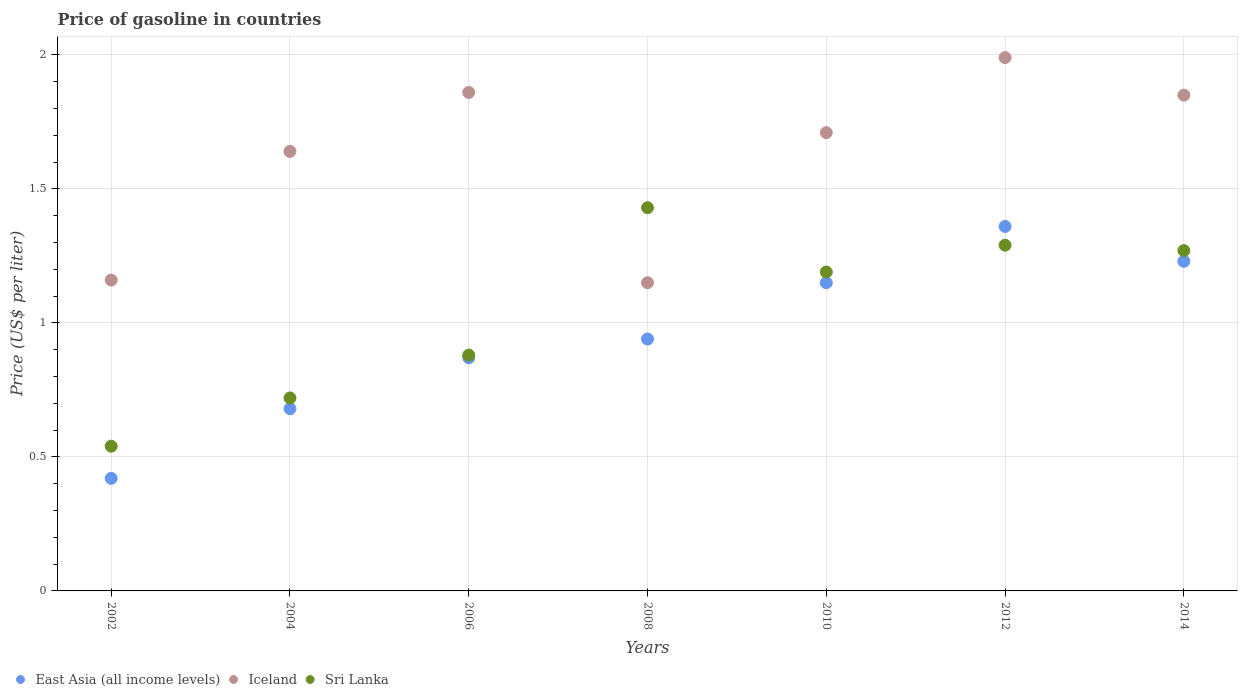How many different coloured dotlines are there?
Ensure brevity in your answer.  3. Is the number of dotlines equal to the number of legend labels?
Provide a short and direct response. Yes. What is the price of gasoline in Iceland in 2012?
Offer a terse response. 1.99. Across all years, what is the maximum price of gasoline in Iceland?
Your answer should be very brief. 1.99. Across all years, what is the minimum price of gasoline in East Asia (all income levels)?
Your answer should be compact. 0.42. In which year was the price of gasoline in Iceland minimum?
Give a very brief answer. 2008. What is the total price of gasoline in Iceland in the graph?
Offer a terse response. 11.36. What is the difference between the price of gasoline in Sri Lanka in 2008 and that in 2014?
Offer a terse response. 0.16. What is the difference between the price of gasoline in East Asia (all income levels) in 2014 and the price of gasoline in Sri Lanka in 2010?
Make the answer very short. 0.04. What is the average price of gasoline in Iceland per year?
Provide a short and direct response. 1.62. In the year 2008, what is the difference between the price of gasoline in Sri Lanka and price of gasoline in Iceland?
Keep it short and to the point. 0.28. What is the ratio of the price of gasoline in Sri Lanka in 2002 to that in 2006?
Your response must be concise. 0.61. Is the price of gasoline in Iceland in 2008 less than that in 2014?
Your response must be concise. Yes. Is the difference between the price of gasoline in Sri Lanka in 2002 and 2006 greater than the difference between the price of gasoline in Iceland in 2002 and 2006?
Offer a very short reply. Yes. What is the difference between the highest and the second highest price of gasoline in Iceland?
Make the answer very short. 0.13. What is the difference between the highest and the lowest price of gasoline in Sri Lanka?
Provide a succinct answer. 0.89. Is it the case that in every year, the sum of the price of gasoline in East Asia (all income levels) and price of gasoline in Iceland  is greater than the price of gasoline in Sri Lanka?
Keep it short and to the point. Yes. Does the price of gasoline in Sri Lanka monotonically increase over the years?
Give a very brief answer. No. Is the price of gasoline in Iceland strictly greater than the price of gasoline in East Asia (all income levels) over the years?
Offer a very short reply. Yes. Is the price of gasoline in Sri Lanka strictly less than the price of gasoline in Iceland over the years?
Your answer should be very brief. No. How many dotlines are there?
Offer a terse response. 3. How many years are there in the graph?
Offer a terse response. 7. What is the difference between two consecutive major ticks on the Y-axis?
Your answer should be compact. 0.5. Are the values on the major ticks of Y-axis written in scientific E-notation?
Provide a succinct answer. No. Does the graph contain grids?
Provide a short and direct response. Yes. How many legend labels are there?
Keep it short and to the point. 3. How are the legend labels stacked?
Offer a terse response. Horizontal. What is the title of the graph?
Ensure brevity in your answer.  Price of gasoline in countries. What is the label or title of the Y-axis?
Provide a short and direct response. Price (US$ per liter). What is the Price (US$ per liter) of East Asia (all income levels) in 2002?
Make the answer very short. 0.42. What is the Price (US$ per liter) in Iceland in 2002?
Ensure brevity in your answer.  1.16. What is the Price (US$ per liter) in Sri Lanka in 2002?
Offer a terse response. 0.54. What is the Price (US$ per liter) in East Asia (all income levels) in 2004?
Provide a short and direct response. 0.68. What is the Price (US$ per liter) of Iceland in 2004?
Your response must be concise. 1.64. What is the Price (US$ per liter) in Sri Lanka in 2004?
Offer a terse response. 0.72. What is the Price (US$ per liter) in East Asia (all income levels) in 2006?
Offer a very short reply. 0.87. What is the Price (US$ per liter) in Iceland in 2006?
Your response must be concise. 1.86. What is the Price (US$ per liter) in Sri Lanka in 2006?
Give a very brief answer. 0.88. What is the Price (US$ per liter) in East Asia (all income levels) in 2008?
Provide a short and direct response. 0.94. What is the Price (US$ per liter) of Iceland in 2008?
Your answer should be very brief. 1.15. What is the Price (US$ per liter) of Sri Lanka in 2008?
Your response must be concise. 1.43. What is the Price (US$ per liter) in East Asia (all income levels) in 2010?
Your answer should be compact. 1.15. What is the Price (US$ per liter) in Iceland in 2010?
Keep it short and to the point. 1.71. What is the Price (US$ per liter) in Sri Lanka in 2010?
Offer a very short reply. 1.19. What is the Price (US$ per liter) of East Asia (all income levels) in 2012?
Your answer should be very brief. 1.36. What is the Price (US$ per liter) of Iceland in 2012?
Offer a terse response. 1.99. What is the Price (US$ per liter) in Sri Lanka in 2012?
Offer a terse response. 1.29. What is the Price (US$ per liter) of East Asia (all income levels) in 2014?
Provide a succinct answer. 1.23. What is the Price (US$ per liter) of Iceland in 2014?
Give a very brief answer. 1.85. What is the Price (US$ per liter) in Sri Lanka in 2014?
Your response must be concise. 1.27. Across all years, what is the maximum Price (US$ per liter) in East Asia (all income levels)?
Provide a succinct answer. 1.36. Across all years, what is the maximum Price (US$ per liter) in Iceland?
Offer a terse response. 1.99. Across all years, what is the maximum Price (US$ per liter) in Sri Lanka?
Ensure brevity in your answer.  1.43. Across all years, what is the minimum Price (US$ per liter) in East Asia (all income levels)?
Your response must be concise. 0.42. Across all years, what is the minimum Price (US$ per liter) of Iceland?
Keep it short and to the point. 1.15. Across all years, what is the minimum Price (US$ per liter) of Sri Lanka?
Ensure brevity in your answer.  0.54. What is the total Price (US$ per liter) in East Asia (all income levels) in the graph?
Keep it short and to the point. 6.65. What is the total Price (US$ per liter) in Iceland in the graph?
Your answer should be very brief. 11.36. What is the total Price (US$ per liter) of Sri Lanka in the graph?
Offer a terse response. 7.32. What is the difference between the Price (US$ per liter) of East Asia (all income levels) in 2002 and that in 2004?
Ensure brevity in your answer.  -0.26. What is the difference between the Price (US$ per liter) of Iceland in 2002 and that in 2004?
Your answer should be compact. -0.48. What is the difference between the Price (US$ per liter) in Sri Lanka in 2002 and that in 2004?
Your answer should be compact. -0.18. What is the difference between the Price (US$ per liter) of East Asia (all income levels) in 2002 and that in 2006?
Provide a short and direct response. -0.45. What is the difference between the Price (US$ per liter) of Iceland in 2002 and that in 2006?
Provide a succinct answer. -0.7. What is the difference between the Price (US$ per liter) in Sri Lanka in 2002 and that in 2006?
Keep it short and to the point. -0.34. What is the difference between the Price (US$ per liter) in East Asia (all income levels) in 2002 and that in 2008?
Provide a succinct answer. -0.52. What is the difference between the Price (US$ per liter) in Iceland in 2002 and that in 2008?
Offer a very short reply. 0.01. What is the difference between the Price (US$ per liter) of Sri Lanka in 2002 and that in 2008?
Your response must be concise. -0.89. What is the difference between the Price (US$ per liter) in East Asia (all income levels) in 2002 and that in 2010?
Keep it short and to the point. -0.73. What is the difference between the Price (US$ per liter) in Iceland in 2002 and that in 2010?
Your response must be concise. -0.55. What is the difference between the Price (US$ per liter) in Sri Lanka in 2002 and that in 2010?
Offer a terse response. -0.65. What is the difference between the Price (US$ per liter) in East Asia (all income levels) in 2002 and that in 2012?
Make the answer very short. -0.94. What is the difference between the Price (US$ per liter) in Iceland in 2002 and that in 2012?
Ensure brevity in your answer.  -0.83. What is the difference between the Price (US$ per liter) in Sri Lanka in 2002 and that in 2012?
Provide a succinct answer. -0.75. What is the difference between the Price (US$ per liter) in East Asia (all income levels) in 2002 and that in 2014?
Provide a short and direct response. -0.81. What is the difference between the Price (US$ per liter) of Iceland in 2002 and that in 2014?
Provide a succinct answer. -0.69. What is the difference between the Price (US$ per liter) of Sri Lanka in 2002 and that in 2014?
Offer a terse response. -0.73. What is the difference between the Price (US$ per liter) of East Asia (all income levels) in 2004 and that in 2006?
Ensure brevity in your answer.  -0.19. What is the difference between the Price (US$ per liter) of Iceland in 2004 and that in 2006?
Provide a short and direct response. -0.22. What is the difference between the Price (US$ per liter) in Sri Lanka in 2004 and that in 2006?
Ensure brevity in your answer.  -0.16. What is the difference between the Price (US$ per liter) in East Asia (all income levels) in 2004 and that in 2008?
Offer a terse response. -0.26. What is the difference between the Price (US$ per liter) of Iceland in 2004 and that in 2008?
Provide a succinct answer. 0.49. What is the difference between the Price (US$ per liter) in Sri Lanka in 2004 and that in 2008?
Ensure brevity in your answer.  -0.71. What is the difference between the Price (US$ per liter) of East Asia (all income levels) in 2004 and that in 2010?
Provide a short and direct response. -0.47. What is the difference between the Price (US$ per liter) of Iceland in 2004 and that in 2010?
Offer a very short reply. -0.07. What is the difference between the Price (US$ per liter) of Sri Lanka in 2004 and that in 2010?
Provide a succinct answer. -0.47. What is the difference between the Price (US$ per liter) of East Asia (all income levels) in 2004 and that in 2012?
Offer a very short reply. -0.68. What is the difference between the Price (US$ per liter) of Iceland in 2004 and that in 2012?
Give a very brief answer. -0.35. What is the difference between the Price (US$ per liter) of Sri Lanka in 2004 and that in 2012?
Provide a succinct answer. -0.57. What is the difference between the Price (US$ per liter) in East Asia (all income levels) in 2004 and that in 2014?
Your answer should be compact. -0.55. What is the difference between the Price (US$ per liter) of Iceland in 2004 and that in 2014?
Provide a short and direct response. -0.21. What is the difference between the Price (US$ per liter) of Sri Lanka in 2004 and that in 2014?
Ensure brevity in your answer.  -0.55. What is the difference between the Price (US$ per liter) in East Asia (all income levels) in 2006 and that in 2008?
Provide a succinct answer. -0.07. What is the difference between the Price (US$ per liter) in Iceland in 2006 and that in 2008?
Offer a very short reply. 0.71. What is the difference between the Price (US$ per liter) in Sri Lanka in 2006 and that in 2008?
Ensure brevity in your answer.  -0.55. What is the difference between the Price (US$ per liter) in East Asia (all income levels) in 2006 and that in 2010?
Offer a terse response. -0.28. What is the difference between the Price (US$ per liter) of Iceland in 2006 and that in 2010?
Your response must be concise. 0.15. What is the difference between the Price (US$ per liter) in Sri Lanka in 2006 and that in 2010?
Provide a short and direct response. -0.31. What is the difference between the Price (US$ per liter) in East Asia (all income levels) in 2006 and that in 2012?
Offer a terse response. -0.49. What is the difference between the Price (US$ per liter) in Iceland in 2006 and that in 2012?
Ensure brevity in your answer.  -0.13. What is the difference between the Price (US$ per liter) of Sri Lanka in 2006 and that in 2012?
Provide a short and direct response. -0.41. What is the difference between the Price (US$ per liter) in East Asia (all income levels) in 2006 and that in 2014?
Your answer should be very brief. -0.36. What is the difference between the Price (US$ per liter) in Iceland in 2006 and that in 2014?
Make the answer very short. 0.01. What is the difference between the Price (US$ per liter) in Sri Lanka in 2006 and that in 2014?
Provide a succinct answer. -0.39. What is the difference between the Price (US$ per liter) of East Asia (all income levels) in 2008 and that in 2010?
Make the answer very short. -0.21. What is the difference between the Price (US$ per liter) in Iceland in 2008 and that in 2010?
Keep it short and to the point. -0.56. What is the difference between the Price (US$ per liter) in Sri Lanka in 2008 and that in 2010?
Keep it short and to the point. 0.24. What is the difference between the Price (US$ per liter) of East Asia (all income levels) in 2008 and that in 2012?
Offer a very short reply. -0.42. What is the difference between the Price (US$ per liter) in Iceland in 2008 and that in 2012?
Your answer should be compact. -0.84. What is the difference between the Price (US$ per liter) of Sri Lanka in 2008 and that in 2012?
Offer a very short reply. 0.14. What is the difference between the Price (US$ per liter) of East Asia (all income levels) in 2008 and that in 2014?
Ensure brevity in your answer.  -0.29. What is the difference between the Price (US$ per liter) in Iceland in 2008 and that in 2014?
Offer a terse response. -0.7. What is the difference between the Price (US$ per liter) in Sri Lanka in 2008 and that in 2014?
Your answer should be compact. 0.16. What is the difference between the Price (US$ per liter) in East Asia (all income levels) in 2010 and that in 2012?
Your answer should be very brief. -0.21. What is the difference between the Price (US$ per liter) of Iceland in 2010 and that in 2012?
Give a very brief answer. -0.28. What is the difference between the Price (US$ per liter) of East Asia (all income levels) in 2010 and that in 2014?
Provide a short and direct response. -0.08. What is the difference between the Price (US$ per liter) of Iceland in 2010 and that in 2014?
Make the answer very short. -0.14. What is the difference between the Price (US$ per liter) of Sri Lanka in 2010 and that in 2014?
Your response must be concise. -0.08. What is the difference between the Price (US$ per liter) of East Asia (all income levels) in 2012 and that in 2014?
Provide a short and direct response. 0.13. What is the difference between the Price (US$ per liter) of Iceland in 2012 and that in 2014?
Provide a short and direct response. 0.14. What is the difference between the Price (US$ per liter) of East Asia (all income levels) in 2002 and the Price (US$ per liter) of Iceland in 2004?
Make the answer very short. -1.22. What is the difference between the Price (US$ per liter) of East Asia (all income levels) in 2002 and the Price (US$ per liter) of Sri Lanka in 2004?
Give a very brief answer. -0.3. What is the difference between the Price (US$ per liter) in Iceland in 2002 and the Price (US$ per liter) in Sri Lanka in 2004?
Make the answer very short. 0.44. What is the difference between the Price (US$ per liter) of East Asia (all income levels) in 2002 and the Price (US$ per liter) of Iceland in 2006?
Provide a short and direct response. -1.44. What is the difference between the Price (US$ per liter) in East Asia (all income levels) in 2002 and the Price (US$ per liter) in Sri Lanka in 2006?
Ensure brevity in your answer.  -0.46. What is the difference between the Price (US$ per liter) of Iceland in 2002 and the Price (US$ per liter) of Sri Lanka in 2006?
Ensure brevity in your answer.  0.28. What is the difference between the Price (US$ per liter) of East Asia (all income levels) in 2002 and the Price (US$ per liter) of Iceland in 2008?
Give a very brief answer. -0.73. What is the difference between the Price (US$ per liter) in East Asia (all income levels) in 2002 and the Price (US$ per liter) in Sri Lanka in 2008?
Keep it short and to the point. -1.01. What is the difference between the Price (US$ per liter) of Iceland in 2002 and the Price (US$ per liter) of Sri Lanka in 2008?
Provide a succinct answer. -0.27. What is the difference between the Price (US$ per liter) in East Asia (all income levels) in 2002 and the Price (US$ per liter) in Iceland in 2010?
Give a very brief answer. -1.29. What is the difference between the Price (US$ per liter) of East Asia (all income levels) in 2002 and the Price (US$ per liter) of Sri Lanka in 2010?
Ensure brevity in your answer.  -0.77. What is the difference between the Price (US$ per liter) in Iceland in 2002 and the Price (US$ per liter) in Sri Lanka in 2010?
Keep it short and to the point. -0.03. What is the difference between the Price (US$ per liter) in East Asia (all income levels) in 2002 and the Price (US$ per liter) in Iceland in 2012?
Keep it short and to the point. -1.57. What is the difference between the Price (US$ per liter) of East Asia (all income levels) in 2002 and the Price (US$ per liter) of Sri Lanka in 2012?
Your answer should be compact. -0.87. What is the difference between the Price (US$ per liter) of Iceland in 2002 and the Price (US$ per liter) of Sri Lanka in 2012?
Offer a terse response. -0.13. What is the difference between the Price (US$ per liter) of East Asia (all income levels) in 2002 and the Price (US$ per liter) of Iceland in 2014?
Your answer should be very brief. -1.43. What is the difference between the Price (US$ per liter) in East Asia (all income levels) in 2002 and the Price (US$ per liter) in Sri Lanka in 2014?
Offer a very short reply. -0.85. What is the difference between the Price (US$ per liter) of Iceland in 2002 and the Price (US$ per liter) of Sri Lanka in 2014?
Ensure brevity in your answer.  -0.11. What is the difference between the Price (US$ per liter) of East Asia (all income levels) in 2004 and the Price (US$ per liter) of Iceland in 2006?
Offer a terse response. -1.18. What is the difference between the Price (US$ per liter) in Iceland in 2004 and the Price (US$ per liter) in Sri Lanka in 2006?
Keep it short and to the point. 0.76. What is the difference between the Price (US$ per liter) of East Asia (all income levels) in 2004 and the Price (US$ per liter) of Iceland in 2008?
Ensure brevity in your answer.  -0.47. What is the difference between the Price (US$ per liter) in East Asia (all income levels) in 2004 and the Price (US$ per liter) in Sri Lanka in 2008?
Provide a succinct answer. -0.75. What is the difference between the Price (US$ per liter) of Iceland in 2004 and the Price (US$ per liter) of Sri Lanka in 2008?
Provide a short and direct response. 0.21. What is the difference between the Price (US$ per liter) in East Asia (all income levels) in 2004 and the Price (US$ per liter) in Iceland in 2010?
Make the answer very short. -1.03. What is the difference between the Price (US$ per liter) in East Asia (all income levels) in 2004 and the Price (US$ per liter) in Sri Lanka in 2010?
Offer a terse response. -0.51. What is the difference between the Price (US$ per liter) of Iceland in 2004 and the Price (US$ per liter) of Sri Lanka in 2010?
Make the answer very short. 0.45. What is the difference between the Price (US$ per liter) in East Asia (all income levels) in 2004 and the Price (US$ per liter) in Iceland in 2012?
Keep it short and to the point. -1.31. What is the difference between the Price (US$ per liter) in East Asia (all income levels) in 2004 and the Price (US$ per liter) in Sri Lanka in 2012?
Ensure brevity in your answer.  -0.61. What is the difference between the Price (US$ per liter) of Iceland in 2004 and the Price (US$ per liter) of Sri Lanka in 2012?
Your answer should be very brief. 0.35. What is the difference between the Price (US$ per liter) in East Asia (all income levels) in 2004 and the Price (US$ per liter) in Iceland in 2014?
Keep it short and to the point. -1.17. What is the difference between the Price (US$ per liter) of East Asia (all income levels) in 2004 and the Price (US$ per liter) of Sri Lanka in 2014?
Offer a very short reply. -0.59. What is the difference between the Price (US$ per liter) in Iceland in 2004 and the Price (US$ per liter) in Sri Lanka in 2014?
Offer a terse response. 0.37. What is the difference between the Price (US$ per liter) of East Asia (all income levels) in 2006 and the Price (US$ per liter) of Iceland in 2008?
Make the answer very short. -0.28. What is the difference between the Price (US$ per liter) of East Asia (all income levels) in 2006 and the Price (US$ per liter) of Sri Lanka in 2008?
Offer a very short reply. -0.56. What is the difference between the Price (US$ per liter) of Iceland in 2006 and the Price (US$ per liter) of Sri Lanka in 2008?
Make the answer very short. 0.43. What is the difference between the Price (US$ per liter) in East Asia (all income levels) in 2006 and the Price (US$ per liter) in Iceland in 2010?
Your response must be concise. -0.84. What is the difference between the Price (US$ per liter) of East Asia (all income levels) in 2006 and the Price (US$ per liter) of Sri Lanka in 2010?
Your response must be concise. -0.32. What is the difference between the Price (US$ per liter) in Iceland in 2006 and the Price (US$ per liter) in Sri Lanka in 2010?
Provide a short and direct response. 0.67. What is the difference between the Price (US$ per liter) in East Asia (all income levels) in 2006 and the Price (US$ per liter) in Iceland in 2012?
Give a very brief answer. -1.12. What is the difference between the Price (US$ per liter) of East Asia (all income levels) in 2006 and the Price (US$ per liter) of Sri Lanka in 2012?
Your response must be concise. -0.42. What is the difference between the Price (US$ per liter) in Iceland in 2006 and the Price (US$ per liter) in Sri Lanka in 2012?
Provide a short and direct response. 0.57. What is the difference between the Price (US$ per liter) in East Asia (all income levels) in 2006 and the Price (US$ per liter) in Iceland in 2014?
Offer a very short reply. -0.98. What is the difference between the Price (US$ per liter) of East Asia (all income levels) in 2006 and the Price (US$ per liter) of Sri Lanka in 2014?
Provide a short and direct response. -0.4. What is the difference between the Price (US$ per liter) of Iceland in 2006 and the Price (US$ per liter) of Sri Lanka in 2014?
Provide a short and direct response. 0.59. What is the difference between the Price (US$ per liter) of East Asia (all income levels) in 2008 and the Price (US$ per liter) of Iceland in 2010?
Offer a very short reply. -0.77. What is the difference between the Price (US$ per liter) of Iceland in 2008 and the Price (US$ per liter) of Sri Lanka in 2010?
Provide a short and direct response. -0.04. What is the difference between the Price (US$ per liter) of East Asia (all income levels) in 2008 and the Price (US$ per liter) of Iceland in 2012?
Provide a succinct answer. -1.05. What is the difference between the Price (US$ per liter) of East Asia (all income levels) in 2008 and the Price (US$ per liter) of Sri Lanka in 2012?
Your answer should be compact. -0.35. What is the difference between the Price (US$ per liter) in Iceland in 2008 and the Price (US$ per liter) in Sri Lanka in 2012?
Provide a succinct answer. -0.14. What is the difference between the Price (US$ per liter) of East Asia (all income levels) in 2008 and the Price (US$ per liter) of Iceland in 2014?
Offer a terse response. -0.91. What is the difference between the Price (US$ per liter) of East Asia (all income levels) in 2008 and the Price (US$ per liter) of Sri Lanka in 2014?
Make the answer very short. -0.33. What is the difference between the Price (US$ per liter) in Iceland in 2008 and the Price (US$ per liter) in Sri Lanka in 2014?
Ensure brevity in your answer.  -0.12. What is the difference between the Price (US$ per liter) in East Asia (all income levels) in 2010 and the Price (US$ per liter) in Iceland in 2012?
Give a very brief answer. -0.84. What is the difference between the Price (US$ per liter) of East Asia (all income levels) in 2010 and the Price (US$ per liter) of Sri Lanka in 2012?
Offer a terse response. -0.14. What is the difference between the Price (US$ per liter) in Iceland in 2010 and the Price (US$ per liter) in Sri Lanka in 2012?
Give a very brief answer. 0.42. What is the difference between the Price (US$ per liter) of East Asia (all income levels) in 2010 and the Price (US$ per liter) of Iceland in 2014?
Offer a very short reply. -0.7. What is the difference between the Price (US$ per liter) of East Asia (all income levels) in 2010 and the Price (US$ per liter) of Sri Lanka in 2014?
Keep it short and to the point. -0.12. What is the difference between the Price (US$ per liter) in Iceland in 2010 and the Price (US$ per liter) in Sri Lanka in 2014?
Your answer should be compact. 0.44. What is the difference between the Price (US$ per liter) in East Asia (all income levels) in 2012 and the Price (US$ per liter) in Iceland in 2014?
Provide a short and direct response. -0.49. What is the difference between the Price (US$ per liter) of East Asia (all income levels) in 2012 and the Price (US$ per liter) of Sri Lanka in 2014?
Ensure brevity in your answer.  0.09. What is the difference between the Price (US$ per liter) in Iceland in 2012 and the Price (US$ per liter) in Sri Lanka in 2014?
Your answer should be very brief. 0.72. What is the average Price (US$ per liter) of Iceland per year?
Your answer should be very brief. 1.62. What is the average Price (US$ per liter) in Sri Lanka per year?
Give a very brief answer. 1.05. In the year 2002, what is the difference between the Price (US$ per liter) in East Asia (all income levels) and Price (US$ per liter) in Iceland?
Offer a terse response. -0.74. In the year 2002, what is the difference between the Price (US$ per liter) in East Asia (all income levels) and Price (US$ per liter) in Sri Lanka?
Your response must be concise. -0.12. In the year 2002, what is the difference between the Price (US$ per liter) of Iceland and Price (US$ per liter) of Sri Lanka?
Your answer should be compact. 0.62. In the year 2004, what is the difference between the Price (US$ per liter) of East Asia (all income levels) and Price (US$ per liter) of Iceland?
Give a very brief answer. -0.96. In the year 2004, what is the difference between the Price (US$ per liter) of East Asia (all income levels) and Price (US$ per liter) of Sri Lanka?
Make the answer very short. -0.04. In the year 2004, what is the difference between the Price (US$ per liter) in Iceland and Price (US$ per liter) in Sri Lanka?
Keep it short and to the point. 0.92. In the year 2006, what is the difference between the Price (US$ per liter) of East Asia (all income levels) and Price (US$ per liter) of Iceland?
Provide a succinct answer. -0.99. In the year 2006, what is the difference between the Price (US$ per liter) in East Asia (all income levels) and Price (US$ per liter) in Sri Lanka?
Provide a succinct answer. -0.01. In the year 2008, what is the difference between the Price (US$ per liter) in East Asia (all income levels) and Price (US$ per liter) in Iceland?
Keep it short and to the point. -0.21. In the year 2008, what is the difference between the Price (US$ per liter) in East Asia (all income levels) and Price (US$ per liter) in Sri Lanka?
Give a very brief answer. -0.49. In the year 2008, what is the difference between the Price (US$ per liter) of Iceland and Price (US$ per liter) of Sri Lanka?
Give a very brief answer. -0.28. In the year 2010, what is the difference between the Price (US$ per liter) in East Asia (all income levels) and Price (US$ per liter) in Iceland?
Your answer should be compact. -0.56. In the year 2010, what is the difference between the Price (US$ per liter) of East Asia (all income levels) and Price (US$ per liter) of Sri Lanka?
Offer a very short reply. -0.04. In the year 2010, what is the difference between the Price (US$ per liter) in Iceland and Price (US$ per liter) in Sri Lanka?
Keep it short and to the point. 0.52. In the year 2012, what is the difference between the Price (US$ per liter) in East Asia (all income levels) and Price (US$ per liter) in Iceland?
Your answer should be very brief. -0.63. In the year 2012, what is the difference between the Price (US$ per liter) in East Asia (all income levels) and Price (US$ per liter) in Sri Lanka?
Offer a terse response. 0.07. In the year 2012, what is the difference between the Price (US$ per liter) of Iceland and Price (US$ per liter) of Sri Lanka?
Give a very brief answer. 0.7. In the year 2014, what is the difference between the Price (US$ per liter) in East Asia (all income levels) and Price (US$ per liter) in Iceland?
Ensure brevity in your answer.  -0.62. In the year 2014, what is the difference between the Price (US$ per liter) of East Asia (all income levels) and Price (US$ per liter) of Sri Lanka?
Your answer should be compact. -0.04. In the year 2014, what is the difference between the Price (US$ per liter) of Iceland and Price (US$ per liter) of Sri Lanka?
Keep it short and to the point. 0.58. What is the ratio of the Price (US$ per liter) of East Asia (all income levels) in 2002 to that in 2004?
Make the answer very short. 0.62. What is the ratio of the Price (US$ per liter) in Iceland in 2002 to that in 2004?
Provide a succinct answer. 0.71. What is the ratio of the Price (US$ per liter) of Sri Lanka in 2002 to that in 2004?
Give a very brief answer. 0.75. What is the ratio of the Price (US$ per liter) in East Asia (all income levels) in 2002 to that in 2006?
Provide a short and direct response. 0.48. What is the ratio of the Price (US$ per liter) of Iceland in 2002 to that in 2006?
Your answer should be compact. 0.62. What is the ratio of the Price (US$ per liter) of Sri Lanka in 2002 to that in 2006?
Offer a very short reply. 0.61. What is the ratio of the Price (US$ per liter) of East Asia (all income levels) in 2002 to that in 2008?
Provide a succinct answer. 0.45. What is the ratio of the Price (US$ per liter) in Iceland in 2002 to that in 2008?
Make the answer very short. 1.01. What is the ratio of the Price (US$ per liter) of Sri Lanka in 2002 to that in 2008?
Offer a very short reply. 0.38. What is the ratio of the Price (US$ per liter) of East Asia (all income levels) in 2002 to that in 2010?
Your answer should be compact. 0.37. What is the ratio of the Price (US$ per liter) of Iceland in 2002 to that in 2010?
Provide a succinct answer. 0.68. What is the ratio of the Price (US$ per liter) of Sri Lanka in 2002 to that in 2010?
Keep it short and to the point. 0.45. What is the ratio of the Price (US$ per liter) in East Asia (all income levels) in 2002 to that in 2012?
Your answer should be compact. 0.31. What is the ratio of the Price (US$ per liter) of Iceland in 2002 to that in 2012?
Your response must be concise. 0.58. What is the ratio of the Price (US$ per liter) of Sri Lanka in 2002 to that in 2012?
Your answer should be very brief. 0.42. What is the ratio of the Price (US$ per liter) in East Asia (all income levels) in 2002 to that in 2014?
Your answer should be very brief. 0.34. What is the ratio of the Price (US$ per liter) in Iceland in 2002 to that in 2014?
Your response must be concise. 0.63. What is the ratio of the Price (US$ per liter) in Sri Lanka in 2002 to that in 2014?
Your answer should be compact. 0.43. What is the ratio of the Price (US$ per liter) in East Asia (all income levels) in 2004 to that in 2006?
Provide a succinct answer. 0.78. What is the ratio of the Price (US$ per liter) in Iceland in 2004 to that in 2006?
Provide a succinct answer. 0.88. What is the ratio of the Price (US$ per liter) in Sri Lanka in 2004 to that in 2006?
Give a very brief answer. 0.82. What is the ratio of the Price (US$ per liter) of East Asia (all income levels) in 2004 to that in 2008?
Offer a very short reply. 0.72. What is the ratio of the Price (US$ per liter) in Iceland in 2004 to that in 2008?
Offer a very short reply. 1.43. What is the ratio of the Price (US$ per liter) in Sri Lanka in 2004 to that in 2008?
Keep it short and to the point. 0.5. What is the ratio of the Price (US$ per liter) in East Asia (all income levels) in 2004 to that in 2010?
Ensure brevity in your answer.  0.59. What is the ratio of the Price (US$ per liter) of Iceland in 2004 to that in 2010?
Offer a terse response. 0.96. What is the ratio of the Price (US$ per liter) of Sri Lanka in 2004 to that in 2010?
Give a very brief answer. 0.6. What is the ratio of the Price (US$ per liter) of East Asia (all income levels) in 2004 to that in 2012?
Provide a short and direct response. 0.5. What is the ratio of the Price (US$ per liter) in Iceland in 2004 to that in 2012?
Keep it short and to the point. 0.82. What is the ratio of the Price (US$ per liter) of Sri Lanka in 2004 to that in 2012?
Your answer should be very brief. 0.56. What is the ratio of the Price (US$ per liter) of East Asia (all income levels) in 2004 to that in 2014?
Your response must be concise. 0.55. What is the ratio of the Price (US$ per liter) in Iceland in 2004 to that in 2014?
Provide a short and direct response. 0.89. What is the ratio of the Price (US$ per liter) in Sri Lanka in 2004 to that in 2014?
Provide a short and direct response. 0.57. What is the ratio of the Price (US$ per liter) of East Asia (all income levels) in 2006 to that in 2008?
Provide a succinct answer. 0.93. What is the ratio of the Price (US$ per liter) of Iceland in 2006 to that in 2008?
Make the answer very short. 1.62. What is the ratio of the Price (US$ per liter) of Sri Lanka in 2006 to that in 2008?
Ensure brevity in your answer.  0.62. What is the ratio of the Price (US$ per liter) in East Asia (all income levels) in 2006 to that in 2010?
Your answer should be very brief. 0.76. What is the ratio of the Price (US$ per liter) in Iceland in 2006 to that in 2010?
Offer a terse response. 1.09. What is the ratio of the Price (US$ per liter) in Sri Lanka in 2006 to that in 2010?
Your answer should be compact. 0.74. What is the ratio of the Price (US$ per liter) of East Asia (all income levels) in 2006 to that in 2012?
Make the answer very short. 0.64. What is the ratio of the Price (US$ per liter) in Iceland in 2006 to that in 2012?
Provide a succinct answer. 0.93. What is the ratio of the Price (US$ per liter) of Sri Lanka in 2006 to that in 2012?
Provide a succinct answer. 0.68. What is the ratio of the Price (US$ per liter) of East Asia (all income levels) in 2006 to that in 2014?
Your answer should be compact. 0.71. What is the ratio of the Price (US$ per liter) of Iceland in 2006 to that in 2014?
Keep it short and to the point. 1.01. What is the ratio of the Price (US$ per liter) of Sri Lanka in 2006 to that in 2014?
Ensure brevity in your answer.  0.69. What is the ratio of the Price (US$ per liter) of East Asia (all income levels) in 2008 to that in 2010?
Give a very brief answer. 0.82. What is the ratio of the Price (US$ per liter) in Iceland in 2008 to that in 2010?
Your response must be concise. 0.67. What is the ratio of the Price (US$ per liter) in Sri Lanka in 2008 to that in 2010?
Give a very brief answer. 1.2. What is the ratio of the Price (US$ per liter) in East Asia (all income levels) in 2008 to that in 2012?
Keep it short and to the point. 0.69. What is the ratio of the Price (US$ per liter) of Iceland in 2008 to that in 2012?
Offer a very short reply. 0.58. What is the ratio of the Price (US$ per liter) in Sri Lanka in 2008 to that in 2012?
Your answer should be very brief. 1.11. What is the ratio of the Price (US$ per liter) in East Asia (all income levels) in 2008 to that in 2014?
Ensure brevity in your answer.  0.76. What is the ratio of the Price (US$ per liter) in Iceland in 2008 to that in 2014?
Your answer should be compact. 0.62. What is the ratio of the Price (US$ per liter) of Sri Lanka in 2008 to that in 2014?
Offer a terse response. 1.13. What is the ratio of the Price (US$ per liter) in East Asia (all income levels) in 2010 to that in 2012?
Provide a succinct answer. 0.85. What is the ratio of the Price (US$ per liter) in Iceland in 2010 to that in 2012?
Offer a terse response. 0.86. What is the ratio of the Price (US$ per liter) in Sri Lanka in 2010 to that in 2012?
Ensure brevity in your answer.  0.92. What is the ratio of the Price (US$ per liter) of East Asia (all income levels) in 2010 to that in 2014?
Ensure brevity in your answer.  0.94. What is the ratio of the Price (US$ per liter) in Iceland in 2010 to that in 2014?
Ensure brevity in your answer.  0.92. What is the ratio of the Price (US$ per liter) in Sri Lanka in 2010 to that in 2014?
Provide a short and direct response. 0.94. What is the ratio of the Price (US$ per liter) in East Asia (all income levels) in 2012 to that in 2014?
Make the answer very short. 1.11. What is the ratio of the Price (US$ per liter) of Iceland in 2012 to that in 2014?
Your response must be concise. 1.08. What is the ratio of the Price (US$ per liter) in Sri Lanka in 2012 to that in 2014?
Make the answer very short. 1.02. What is the difference between the highest and the second highest Price (US$ per liter) in East Asia (all income levels)?
Your answer should be compact. 0.13. What is the difference between the highest and the second highest Price (US$ per liter) in Iceland?
Make the answer very short. 0.13. What is the difference between the highest and the second highest Price (US$ per liter) in Sri Lanka?
Offer a terse response. 0.14. What is the difference between the highest and the lowest Price (US$ per liter) in Iceland?
Ensure brevity in your answer.  0.84. What is the difference between the highest and the lowest Price (US$ per liter) in Sri Lanka?
Make the answer very short. 0.89. 